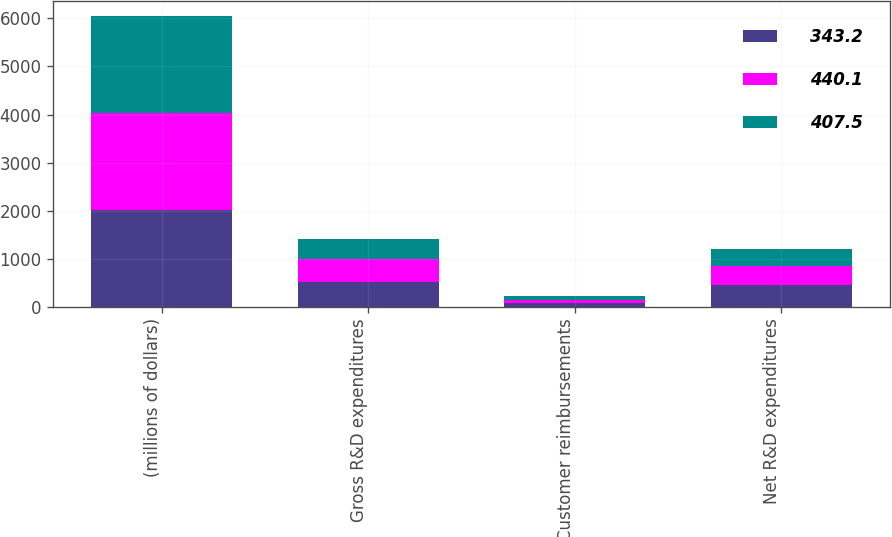<chart> <loc_0><loc_0><loc_500><loc_500><stacked_bar_chart><ecel><fcel>(millions of dollars)<fcel>Gross R&D expenditures<fcel>Customer reimbursements<fcel>Net R&D expenditures<nl><fcel>343.2<fcel>2018<fcel>511.7<fcel>71.6<fcel>440.1<nl><fcel>440.1<fcel>2017<fcel>473.1<fcel>65.6<fcel>407.5<nl><fcel>407.5<fcel>2016<fcel>417.8<fcel>74.6<fcel>343.2<nl></chart> 